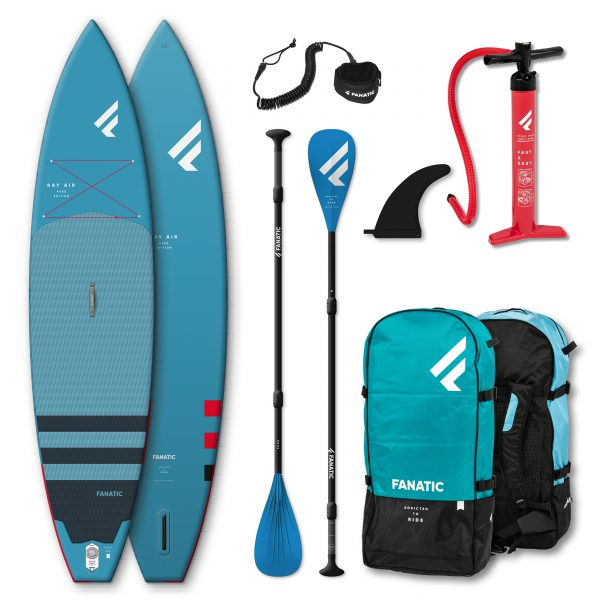Imagine you are planning a day trip using the items in the image. Describe your preparation and key steps or precautions to take. For a day trip using the paddleboarding items in the image, careful preparation and key precautions are essential. Start by checking the weather forecast to ensure favorable conditions. Inspect the paddleboards and other equipment for any damage and ensure the manual pump functions correctly. Pack the adjustable paddles, coiled leash, and fins, and secure them in the backpacks for easy transport. Bring a personal flotation device (PFD) for safety and load a dry bag with essentials like a phone, snacks, water, sunscreen, and a first aid kit. At the launch site, set up the paddleboards using the manual pump and attach the fins securely. Always let someone know your trip plan and expected return time. As a final check, ensure you have enough hydration and sun protection, and be mindful of water currents and surrounding boat traffic during your paddleboarding adventure. Taking these precautions will ensure a safe and enjoyable experience on the water. 